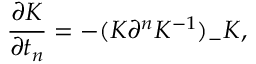<formula> <loc_0><loc_0><loc_500><loc_500>\frac { \partial K } { \partial t _ { n } } = - ( K \partial ^ { n } K ^ { - 1 } ) _ { - } K ,</formula> 